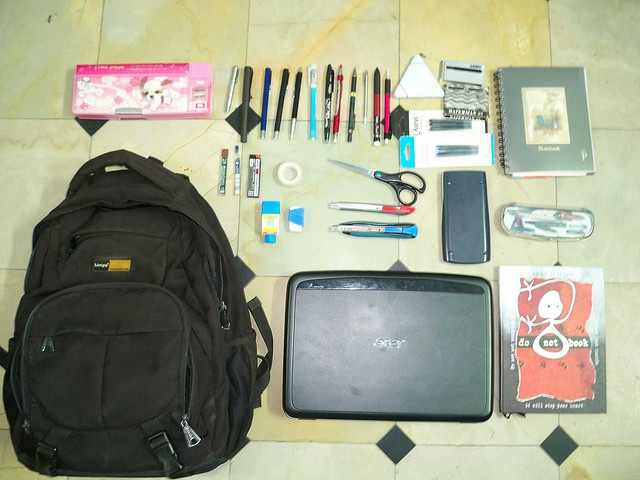Describe the objects in this image and their specific colors. I can see backpack in tan, black, and gray tones, laptop in darkgray and gray tones, book in darkgray, white, salmon, and gray tones, book in darkgray, beige, and gray tones, and cell phone in darkgray, gray, and blue tones in this image. 